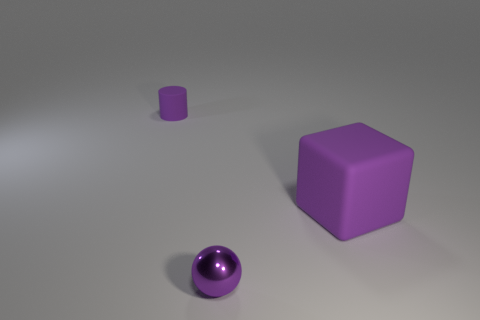There is a object that is the same material as the purple block; what shape is it?
Provide a short and direct response. Cylinder. Is the material of the purple cylinder the same as the tiny purple object that is in front of the big purple rubber block?
Your answer should be compact. No. Is there a tiny purple shiny thing to the left of the object on the right side of the ball?
Give a very brief answer. Yes. What number of purple rubber objects are left of the purple rubber object on the right side of the tiny cylinder?
Make the answer very short. 1. Is there any other thing that is the same color as the big cube?
Your response must be concise. Yes. What number of things are either spheres or shiny balls that are in front of the purple rubber cube?
Your answer should be compact. 1. The purple object that is on the left side of the small purple object on the right side of the purple rubber thing that is to the left of the purple metal ball is made of what material?
Keep it short and to the point. Rubber. There is another thing that is made of the same material as the big thing; what size is it?
Offer a very short reply. Small. There is a matte thing that is on the left side of the small purple object that is to the right of the tiny purple matte cylinder; what is its color?
Provide a succinct answer. Purple. What number of other purple cubes are the same material as the cube?
Offer a very short reply. 0. 